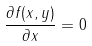Convert formula to latex. <formula><loc_0><loc_0><loc_500><loc_500>\frac { \partial f ( x , y ) } { \partial x } = 0</formula> 